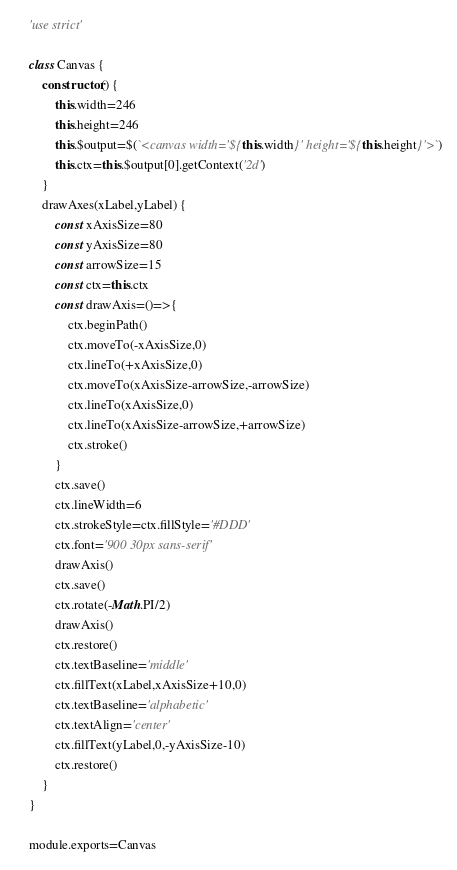<code> <loc_0><loc_0><loc_500><loc_500><_JavaScript_>'use strict'

class Canvas {
	constructor() {
		this.width=246
		this.height=246
		this.$output=$(`<canvas width='${this.width}' height='${this.height}'>`)
		this.ctx=this.$output[0].getContext('2d')
	}
	drawAxes(xLabel,yLabel) {
		const xAxisSize=80
		const yAxisSize=80
		const arrowSize=15
		const ctx=this.ctx
		const drawAxis=()=>{
			ctx.beginPath()
			ctx.moveTo(-xAxisSize,0)
			ctx.lineTo(+xAxisSize,0)
			ctx.moveTo(xAxisSize-arrowSize,-arrowSize)
			ctx.lineTo(xAxisSize,0)
			ctx.lineTo(xAxisSize-arrowSize,+arrowSize)
			ctx.stroke()
		}
		ctx.save()
		ctx.lineWidth=6
		ctx.strokeStyle=ctx.fillStyle='#DDD'
		ctx.font='900 30px sans-serif'
		drawAxis()
		ctx.save()
		ctx.rotate(-Math.PI/2)
		drawAxis()
		ctx.restore()
		ctx.textBaseline='middle'
		ctx.fillText(xLabel,xAxisSize+10,0)
		ctx.textBaseline='alphabetic'
		ctx.textAlign='center'
		ctx.fillText(yLabel,0,-yAxisSize-10)
		ctx.restore()
	}
}

module.exports=Canvas
</code> 